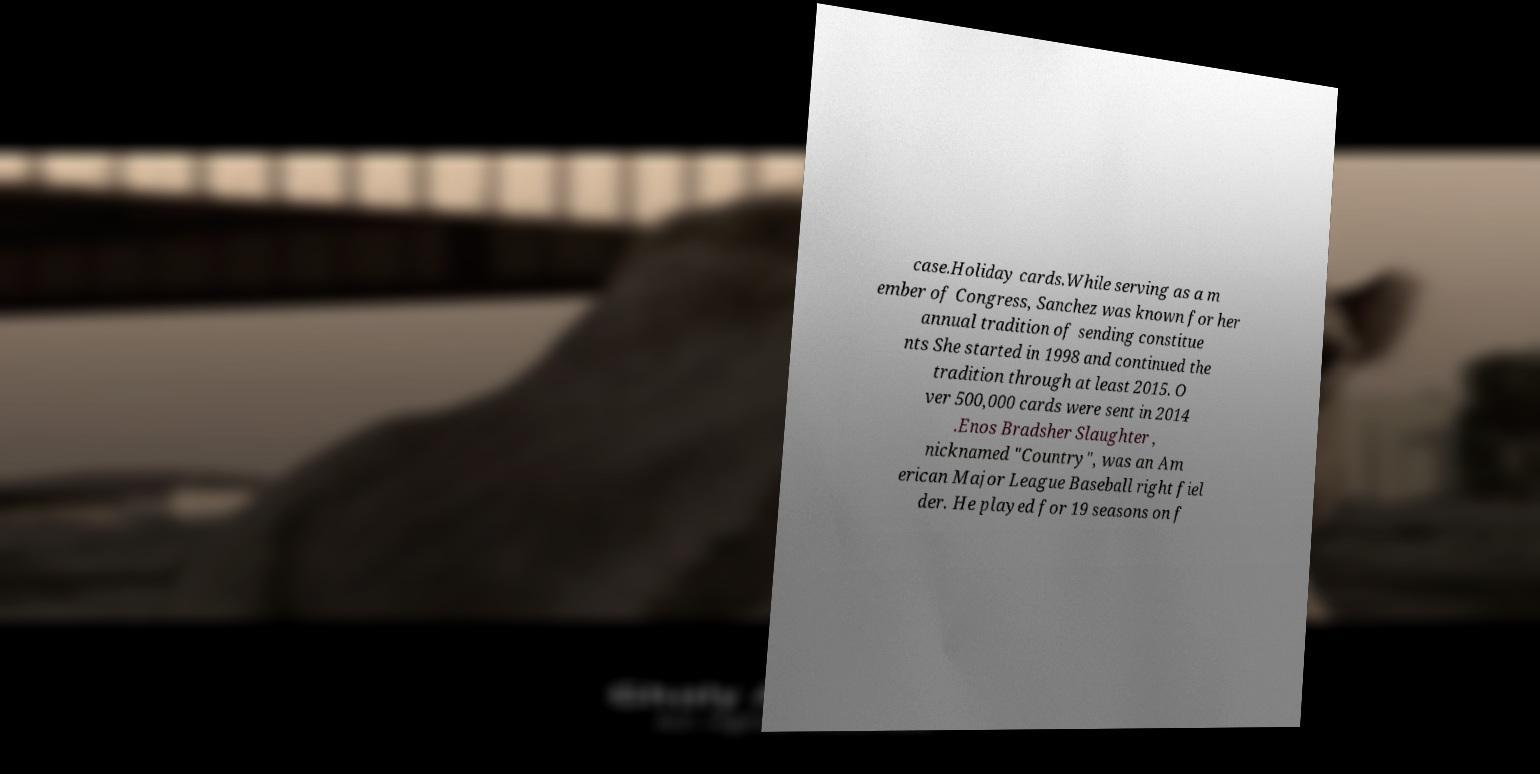Can you read and provide the text displayed in the image?This photo seems to have some interesting text. Can you extract and type it out for me? case.Holiday cards.While serving as a m ember of Congress, Sanchez was known for her annual tradition of sending constitue nts She started in 1998 and continued the tradition through at least 2015. O ver 500,000 cards were sent in 2014 .Enos Bradsher Slaughter , nicknamed "Country", was an Am erican Major League Baseball right fiel der. He played for 19 seasons on f 